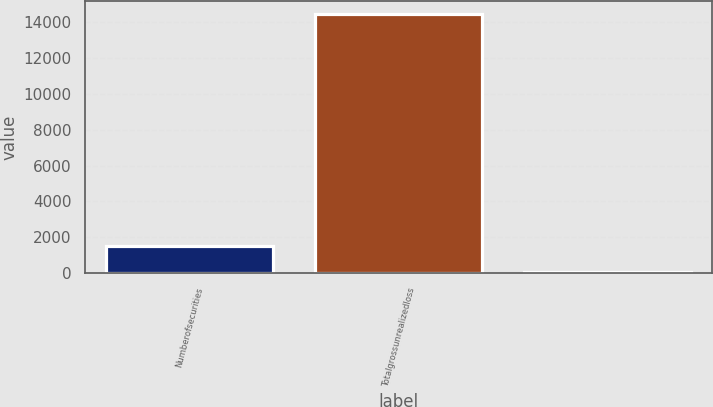Convert chart. <chart><loc_0><loc_0><loc_500><loc_500><bar_chart><fcel>Numberofsecurities<fcel>Totalgrossunrealizedloss<fcel>Unnamed: 2<nl><fcel>1493.5<fcel>14485<fcel>50<nl></chart> 